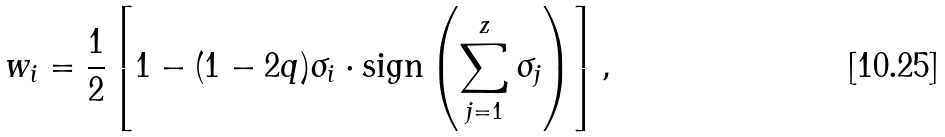Convert formula to latex. <formula><loc_0><loc_0><loc_500><loc_500>w _ { i } = \frac { 1 } { 2 } \left [ 1 - ( 1 - 2 q ) \sigma _ { i } \cdot \text {sign} \left ( \sum _ { j = 1 } ^ { z } \sigma _ { j } \right ) \right ] ,</formula> 